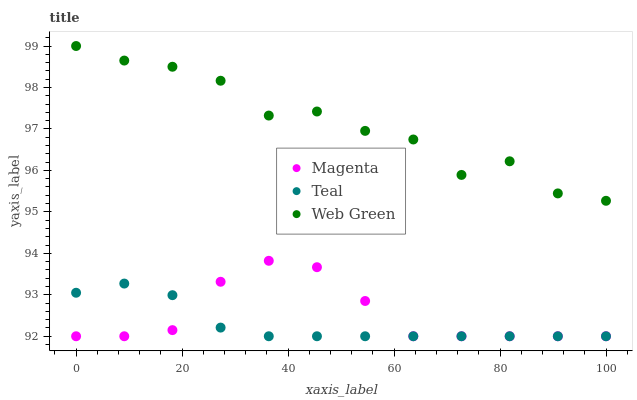Does Teal have the minimum area under the curve?
Answer yes or no. Yes. Does Web Green have the maximum area under the curve?
Answer yes or no. Yes. Does Web Green have the minimum area under the curve?
Answer yes or no. No. Does Teal have the maximum area under the curve?
Answer yes or no. No. Is Teal the smoothest?
Answer yes or no. Yes. Is Web Green the roughest?
Answer yes or no. Yes. Is Web Green the smoothest?
Answer yes or no. No. Is Teal the roughest?
Answer yes or no. No. Does Magenta have the lowest value?
Answer yes or no. Yes. Does Web Green have the lowest value?
Answer yes or no. No. Does Web Green have the highest value?
Answer yes or no. Yes. Does Teal have the highest value?
Answer yes or no. No. Is Teal less than Web Green?
Answer yes or no. Yes. Is Web Green greater than Teal?
Answer yes or no. Yes. Does Magenta intersect Teal?
Answer yes or no. Yes. Is Magenta less than Teal?
Answer yes or no. No. Is Magenta greater than Teal?
Answer yes or no. No. Does Teal intersect Web Green?
Answer yes or no. No. 